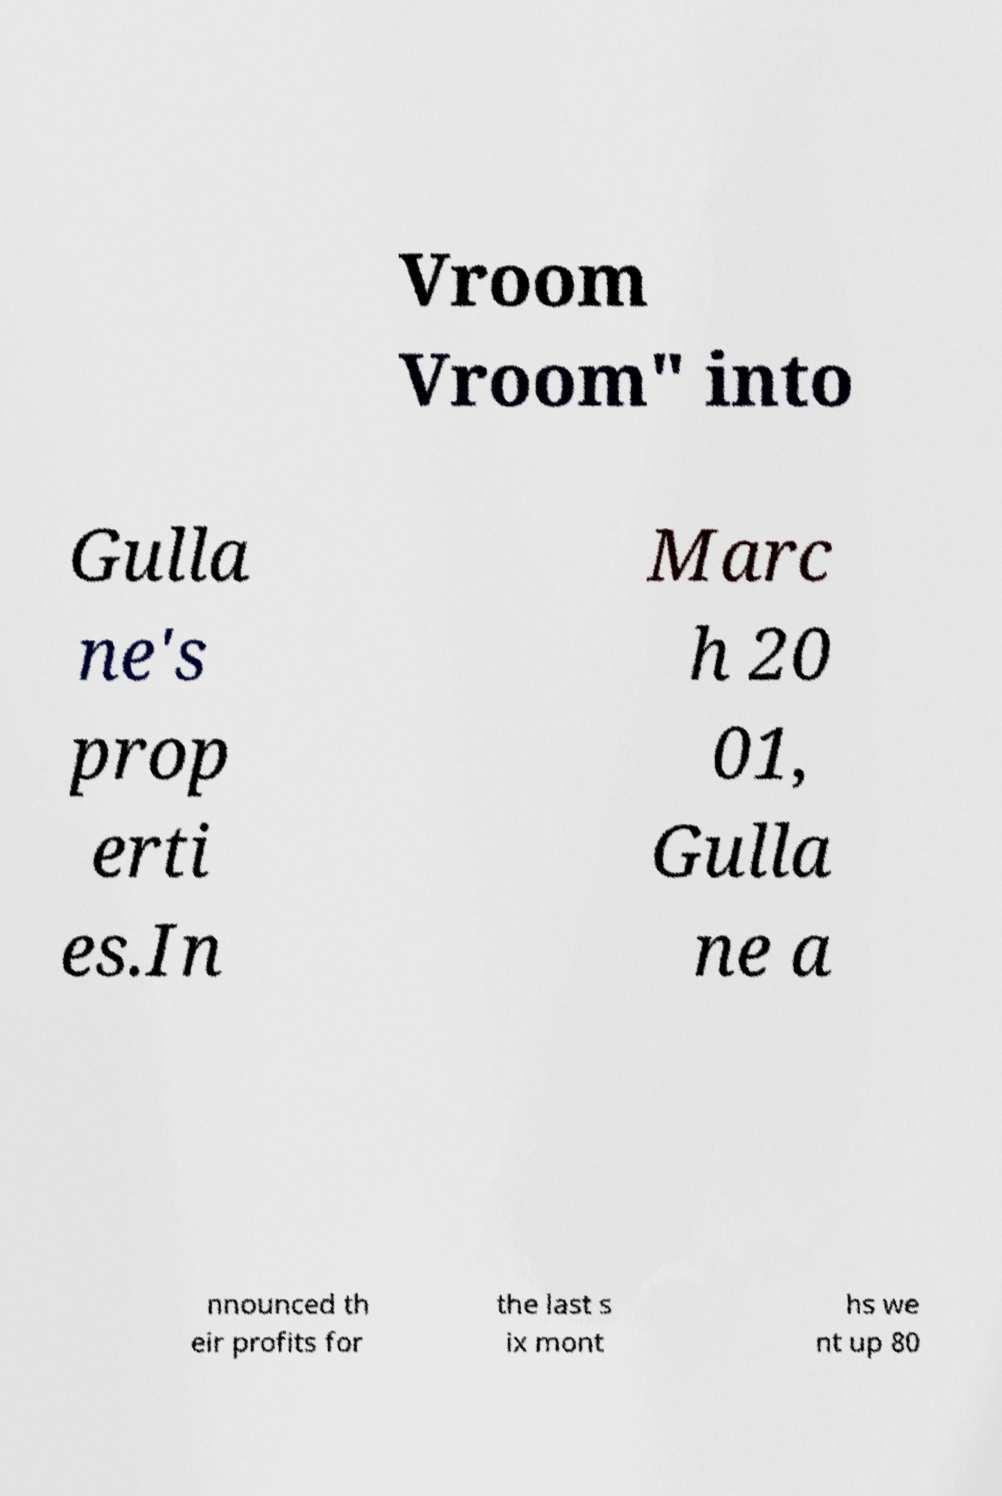Can you read and provide the text displayed in the image?This photo seems to have some interesting text. Can you extract and type it out for me? Vroom Vroom" into Gulla ne's prop erti es.In Marc h 20 01, Gulla ne a nnounced th eir profits for the last s ix mont hs we nt up 80 